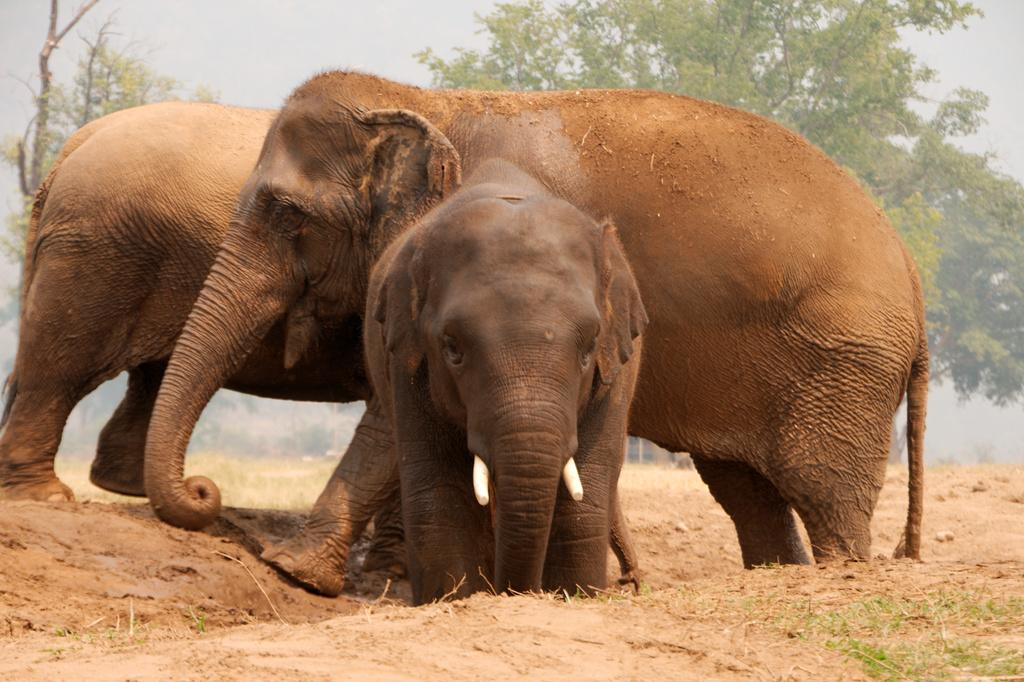How many elephants are in the image? There are three elephants in the image: two adult elephants and a baby elephant. What is the position of the baby elephant in relation to the adult elephants? The baby elephant is in front of the adult elephants. What can be seen in the background of the image? There are trees in the background of the image. What type of metal object is being used by the baby elephant in the image? There is no metal object present in the image; it features three elephants with no additional objects. 